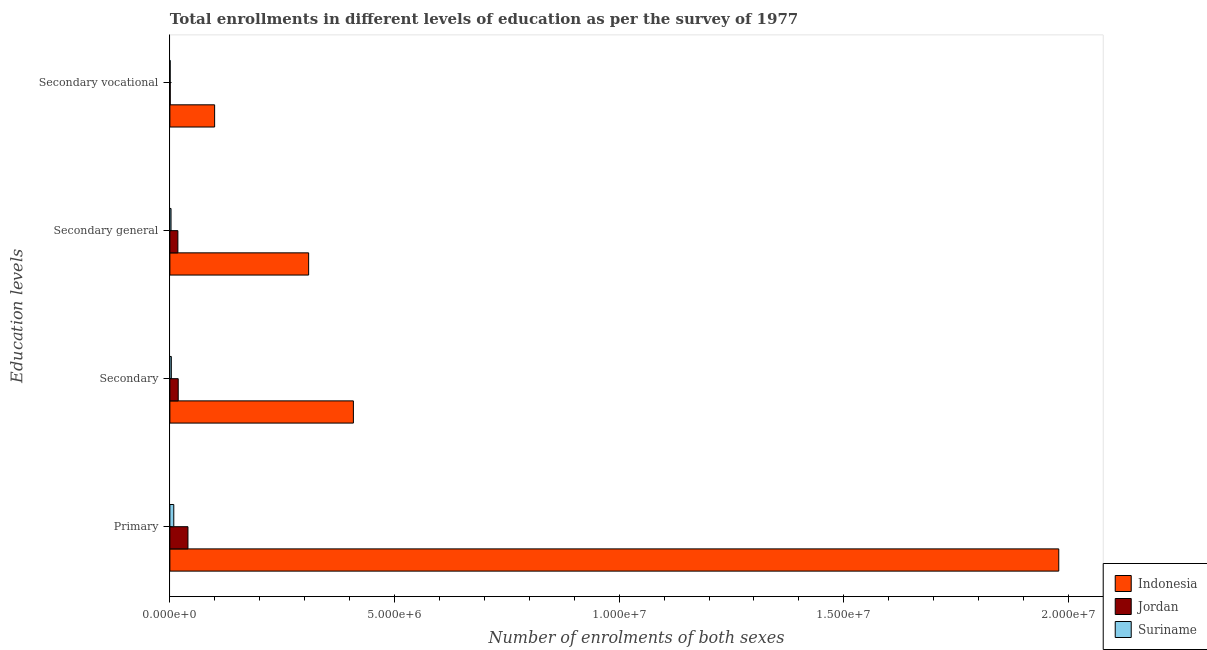How many different coloured bars are there?
Your response must be concise. 3. Are the number of bars per tick equal to the number of legend labels?
Your answer should be compact. Yes. How many bars are there on the 1st tick from the top?
Make the answer very short. 3. How many bars are there on the 2nd tick from the bottom?
Give a very brief answer. 3. What is the label of the 4th group of bars from the top?
Provide a succinct answer. Primary. What is the number of enrolments in primary education in Suriname?
Make the answer very short. 8.70e+04. Across all countries, what is the maximum number of enrolments in primary education?
Your response must be concise. 1.98e+07. Across all countries, what is the minimum number of enrolments in secondary vocational education?
Offer a very short reply. 6375. In which country was the number of enrolments in secondary vocational education maximum?
Your response must be concise. Indonesia. In which country was the number of enrolments in secondary education minimum?
Give a very brief answer. Suriname. What is the total number of enrolments in secondary general education in the graph?
Your answer should be very brief. 3.29e+06. What is the difference between the number of enrolments in secondary general education in Indonesia and that in Jordan?
Make the answer very short. 2.91e+06. What is the difference between the number of enrolments in secondary education in Suriname and the number of enrolments in primary education in Indonesia?
Offer a terse response. -1.98e+07. What is the average number of enrolments in secondary education per country?
Your answer should be very brief. 1.43e+06. What is the difference between the number of enrolments in secondary general education and number of enrolments in secondary vocational education in Suriname?
Offer a very short reply. 1.95e+04. What is the ratio of the number of enrolments in secondary general education in Suriname to that in Jordan?
Offer a very short reply. 0.15. Is the number of enrolments in secondary general education in Jordan less than that in Indonesia?
Your answer should be compact. Yes. Is the difference between the number of enrolments in secondary general education in Jordan and Indonesia greater than the difference between the number of enrolments in secondary vocational education in Jordan and Indonesia?
Ensure brevity in your answer.  No. What is the difference between the highest and the second highest number of enrolments in secondary education?
Offer a terse response. 3.90e+06. What is the difference between the highest and the lowest number of enrolments in primary education?
Your answer should be very brief. 1.97e+07. What does the 1st bar from the top in Secondary general represents?
Provide a succinct answer. Suriname. What does the 3rd bar from the bottom in Secondary represents?
Your response must be concise. Suriname. Is it the case that in every country, the sum of the number of enrolments in primary education and number of enrolments in secondary education is greater than the number of enrolments in secondary general education?
Offer a terse response. Yes. Are all the bars in the graph horizontal?
Offer a terse response. Yes. Are the values on the major ticks of X-axis written in scientific E-notation?
Keep it short and to the point. Yes. Does the graph contain any zero values?
Give a very brief answer. No. How many legend labels are there?
Make the answer very short. 3. What is the title of the graph?
Your answer should be very brief. Total enrollments in different levels of education as per the survey of 1977. Does "Bhutan" appear as one of the legend labels in the graph?
Keep it short and to the point. No. What is the label or title of the X-axis?
Your answer should be very brief. Number of enrolments of both sexes. What is the label or title of the Y-axis?
Keep it short and to the point. Education levels. What is the Number of enrolments of both sexes of Indonesia in Primary?
Your answer should be very brief. 1.98e+07. What is the Number of enrolments of both sexes of Jordan in Primary?
Your response must be concise. 4.02e+05. What is the Number of enrolments of both sexes in Suriname in Primary?
Offer a very short reply. 8.70e+04. What is the Number of enrolments of both sexes of Indonesia in Secondary?
Your answer should be very brief. 4.08e+06. What is the Number of enrolments of both sexes in Jordan in Secondary?
Give a very brief answer. 1.86e+05. What is the Number of enrolments of both sexes of Suriname in Secondary?
Make the answer very short. 3.22e+04. What is the Number of enrolments of both sexes of Indonesia in Secondary general?
Make the answer very short. 3.09e+06. What is the Number of enrolments of both sexes in Jordan in Secondary general?
Give a very brief answer. 1.78e+05. What is the Number of enrolments of both sexes in Suriname in Secondary general?
Your response must be concise. 2.59e+04. What is the Number of enrolments of both sexes of Indonesia in Secondary vocational?
Provide a succinct answer. 9.96e+05. What is the Number of enrolments of both sexes of Jordan in Secondary vocational?
Offer a terse response. 7547. What is the Number of enrolments of both sexes of Suriname in Secondary vocational?
Ensure brevity in your answer.  6375. Across all Education levels, what is the maximum Number of enrolments of both sexes in Indonesia?
Offer a terse response. 1.98e+07. Across all Education levels, what is the maximum Number of enrolments of both sexes in Jordan?
Give a very brief answer. 4.02e+05. Across all Education levels, what is the maximum Number of enrolments of both sexes in Suriname?
Ensure brevity in your answer.  8.70e+04. Across all Education levels, what is the minimum Number of enrolments of both sexes of Indonesia?
Your answer should be very brief. 9.96e+05. Across all Education levels, what is the minimum Number of enrolments of both sexes of Jordan?
Offer a terse response. 7547. Across all Education levels, what is the minimum Number of enrolments of both sexes in Suriname?
Your response must be concise. 6375. What is the total Number of enrolments of both sexes of Indonesia in the graph?
Your answer should be very brief. 2.80e+07. What is the total Number of enrolments of both sexes of Jordan in the graph?
Offer a very short reply. 7.74e+05. What is the total Number of enrolments of both sexes of Suriname in the graph?
Your answer should be compact. 1.51e+05. What is the difference between the Number of enrolments of both sexes of Indonesia in Primary and that in Secondary?
Keep it short and to the point. 1.57e+07. What is the difference between the Number of enrolments of both sexes of Jordan in Primary and that in Secondary?
Your answer should be very brief. 2.17e+05. What is the difference between the Number of enrolments of both sexes in Suriname in Primary and that in Secondary?
Keep it short and to the point. 5.47e+04. What is the difference between the Number of enrolments of both sexes in Indonesia in Primary and that in Secondary general?
Offer a terse response. 1.67e+07. What is the difference between the Number of enrolments of both sexes in Jordan in Primary and that in Secondary general?
Keep it short and to the point. 2.24e+05. What is the difference between the Number of enrolments of both sexes of Suriname in Primary and that in Secondary general?
Ensure brevity in your answer.  6.11e+04. What is the difference between the Number of enrolments of both sexes of Indonesia in Primary and that in Secondary vocational?
Ensure brevity in your answer.  1.88e+07. What is the difference between the Number of enrolments of both sexes in Jordan in Primary and that in Secondary vocational?
Your response must be concise. 3.95e+05. What is the difference between the Number of enrolments of both sexes of Suriname in Primary and that in Secondary vocational?
Make the answer very short. 8.06e+04. What is the difference between the Number of enrolments of both sexes of Indonesia in Secondary and that in Secondary general?
Your answer should be very brief. 9.96e+05. What is the difference between the Number of enrolments of both sexes of Jordan in Secondary and that in Secondary general?
Make the answer very short. 7547. What is the difference between the Number of enrolments of both sexes of Suriname in Secondary and that in Secondary general?
Your answer should be compact. 6375. What is the difference between the Number of enrolments of both sexes of Indonesia in Secondary and that in Secondary vocational?
Keep it short and to the point. 3.09e+06. What is the difference between the Number of enrolments of both sexes in Jordan in Secondary and that in Secondary vocational?
Your answer should be compact. 1.78e+05. What is the difference between the Number of enrolments of both sexes in Suriname in Secondary and that in Secondary vocational?
Give a very brief answer. 2.59e+04. What is the difference between the Number of enrolments of both sexes of Indonesia in Secondary general and that in Secondary vocational?
Provide a short and direct response. 2.09e+06. What is the difference between the Number of enrolments of both sexes in Jordan in Secondary general and that in Secondary vocational?
Give a very brief answer. 1.71e+05. What is the difference between the Number of enrolments of both sexes in Suriname in Secondary general and that in Secondary vocational?
Your answer should be compact. 1.95e+04. What is the difference between the Number of enrolments of both sexes in Indonesia in Primary and the Number of enrolments of both sexes in Jordan in Secondary?
Your response must be concise. 1.96e+07. What is the difference between the Number of enrolments of both sexes of Indonesia in Primary and the Number of enrolments of both sexes of Suriname in Secondary?
Keep it short and to the point. 1.98e+07. What is the difference between the Number of enrolments of both sexes in Jordan in Primary and the Number of enrolments of both sexes in Suriname in Secondary?
Provide a succinct answer. 3.70e+05. What is the difference between the Number of enrolments of both sexes of Indonesia in Primary and the Number of enrolments of both sexes of Jordan in Secondary general?
Your response must be concise. 1.96e+07. What is the difference between the Number of enrolments of both sexes in Indonesia in Primary and the Number of enrolments of both sexes in Suriname in Secondary general?
Offer a terse response. 1.98e+07. What is the difference between the Number of enrolments of both sexes of Jordan in Primary and the Number of enrolments of both sexes of Suriname in Secondary general?
Give a very brief answer. 3.77e+05. What is the difference between the Number of enrolments of both sexes of Indonesia in Primary and the Number of enrolments of both sexes of Jordan in Secondary vocational?
Keep it short and to the point. 1.98e+07. What is the difference between the Number of enrolments of both sexes of Indonesia in Primary and the Number of enrolments of both sexes of Suriname in Secondary vocational?
Your answer should be very brief. 1.98e+07. What is the difference between the Number of enrolments of both sexes of Jordan in Primary and the Number of enrolments of both sexes of Suriname in Secondary vocational?
Give a very brief answer. 3.96e+05. What is the difference between the Number of enrolments of both sexes in Indonesia in Secondary and the Number of enrolments of both sexes in Jordan in Secondary general?
Your response must be concise. 3.91e+06. What is the difference between the Number of enrolments of both sexes of Indonesia in Secondary and the Number of enrolments of both sexes of Suriname in Secondary general?
Your answer should be very brief. 4.06e+06. What is the difference between the Number of enrolments of both sexes in Jordan in Secondary and the Number of enrolments of both sexes in Suriname in Secondary general?
Provide a succinct answer. 1.60e+05. What is the difference between the Number of enrolments of both sexes of Indonesia in Secondary and the Number of enrolments of both sexes of Jordan in Secondary vocational?
Keep it short and to the point. 4.08e+06. What is the difference between the Number of enrolments of both sexes of Indonesia in Secondary and the Number of enrolments of both sexes of Suriname in Secondary vocational?
Offer a very short reply. 4.08e+06. What is the difference between the Number of enrolments of both sexes in Jordan in Secondary and the Number of enrolments of both sexes in Suriname in Secondary vocational?
Ensure brevity in your answer.  1.79e+05. What is the difference between the Number of enrolments of both sexes in Indonesia in Secondary general and the Number of enrolments of both sexes in Jordan in Secondary vocational?
Your answer should be compact. 3.08e+06. What is the difference between the Number of enrolments of both sexes in Indonesia in Secondary general and the Number of enrolments of both sexes in Suriname in Secondary vocational?
Make the answer very short. 3.08e+06. What is the difference between the Number of enrolments of both sexes in Jordan in Secondary general and the Number of enrolments of both sexes in Suriname in Secondary vocational?
Your answer should be compact. 1.72e+05. What is the average Number of enrolments of both sexes of Indonesia per Education levels?
Provide a succinct answer. 6.99e+06. What is the average Number of enrolments of both sexes of Jordan per Education levels?
Make the answer very short. 1.93e+05. What is the average Number of enrolments of both sexes of Suriname per Education levels?
Offer a very short reply. 3.79e+04. What is the difference between the Number of enrolments of both sexes of Indonesia and Number of enrolments of both sexes of Jordan in Primary?
Provide a short and direct response. 1.94e+07. What is the difference between the Number of enrolments of both sexes of Indonesia and Number of enrolments of both sexes of Suriname in Primary?
Keep it short and to the point. 1.97e+07. What is the difference between the Number of enrolments of both sexes of Jordan and Number of enrolments of both sexes of Suriname in Primary?
Provide a short and direct response. 3.15e+05. What is the difference between the Number of enrolments of both sexes in Indonesia and Number of enrolments of both sexes in Jordan in Secondary?
Your answer should be compact. 3.90e+06. What is the difference between the Number of enrolments of both sexes in Indonesia and Number of enrolments of both sexes in Suriname in Secondary?
Offer a very short reply. 4.05e+06. What is the difference between the Number of enrolments of both sexes of Jordan and Number of enrolments of both sexes of Suriname in Secondary?
Make the answer very short. 1.53e+05. What is the difference between the Number of enrolments of both sexes in Indonesia and Number of enrolments of both sexes in Jordan in Secondary general?
Offer a terse response. 2.91e+06. What is the difference between the Number of enrolments of both sexes of Indonesia and Number of enrolments of both sexes of Suriname in Secondary general?
Make the answer very short. 3.06e+06. What is the difference between the Number of enrolments of both sexes of Jordan and Number of enrolments of both sexes of Suriname in Secondary general?
Your answer should be compact. 1.52e+05. What is the difference between the Number of enrolments of both sexes in Indonesia and Number of enrolments of both sexes in Jordan in Secondary vocational?
Make the answer very short. 9.89e+05. What is the difference between the Number of enrolments of both sexes of Indonesia and Number of enrolments of both sexes of Suriname in Secondary vocational?
Your answer should be very brief. 9.90e+05. What is the difference between the Number of enrolments of both sexes of Jordan and Number of enrolments of both sexes of Suriname in Secondary vocational?
Provide a succinct answer. 1172. What is the ratio of the Number of enrolments of both sexes of Indonesia in Primary to that in Secondary?
Offer a terse response. 4.84. What is the ratio of the Number of enrolments of both sexes of Jordan in Primary to that in Secondary?
Offer a terse response. 2.17. What is the ratio of the Number of enrolments of both sexes of Suriname in Primary to that in Secondary?
Keep it short and to the point. 2.7. What is the ratio of the Number of enrolments of both sexes in Indonesia in Primary to that in Secondary general?
Offer a terse response. 6.41. What is the ratio of the Number of enrolments of both sexes in Jordan in Primary to that in Secondary general?
Your answer should be very brief. 2.26. What is the ratio of the Number of enrolments of both sexes of Suriname in Primary to that in Secondary general?
Keep it short and to the point. 3.36. What is the ratio of the Number of enrolments of both sexes of Indonesia in Primary to that in Secondary vocational?
Ensure brevity in your answer.  19.86. What is the ratio of the Number of enrolments of both sexes in Jordan in Primary to that in Secondary vocational?
Provide a succinct answer. 53.32. What is the ratio of the Number of enrolments of both sexes in Suriname in Primary to that in Secondary vocational?
Offer a very short reply. 13.64. What is the ratio of the Number of enrolments of both sexes of Indonesia in Secondary to that in Secondary general?
Keep it short and to the point. 1.32. What is the ratio of the Number of enrolments of both sexes in Jordan in Secondary to that in Secondary general?
Offer a terse response. 1.04. What is the ratio of the Number of enrolments of both sexes in Suriname in Secondary to that in Secondary general?
Ensure brevity in your answer.  1.25. What is the ratio of the Number of enrolments of both sexes of Indonesia in Secondary to that in Secondary vocational?
Provide a succinct answer. 4.1. What is the ratio of the Number of enrolments of both sexes of Jordan in Secondary to that in Secondary vocational?
Offer a very short reply. 24.61. What is the ratio of the Number of enrolments of both sexes in Suriname in Secondary to that in Secondary vocational?
Offer a very short reply. 5.06. What is the ratio of the Number of enrolments of both sexes of Indonesia in Secondary general to that in Secondary vocational?
Your response must be concise. 3.1. What is the ratio of the Number of enrolments of both sexes in Jordan in Secondary general to that in Secondary vocational?
Offer a terse response. 23.61. What is the ratio of the Number of enrolments of both sexes in Suriname in Secondary general to that in Secondary vocational?
Offer a very short reply. 4.06. What is the difference between the highest and the second highest Number of enrolments of both sexes in Indonesia?
Offer a terse response. 1.57e+07. What is the difference between the highest and the second highest Number of enrolments of both sexes of Jordan?
Keep it short and to the point. 2.17e+05. What is the difference between the highest and the second highest Number of enrolments of both sexes of Suriname?
Provide a succinct answer. 5.47e+04. What is the difference between the highest and the lowest Number of enrolments of both sexes of Indonesia?
Provide a short and direct response. 1.88e+07. What is the difference between the highest and the lowest Number of enrolments of both sexes in Jordan?
Make the answer very short. 3.95e+05. What is the difference between the highest and the lowest Number of enrolments of both sexes of Suriname?
Make the answer very short. 8.06e+04. 